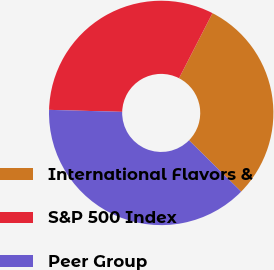Convert chart to OTSL. <chart><loc_0><loc_0><loc_500><loc_500><pie_chart><fcel>International Flavors &<fcel>S&P 500 Index<fcel>Peer Group<nl><fcel>29.82%<fcel>32.12%<fcel>38.06%<nl></chart> 